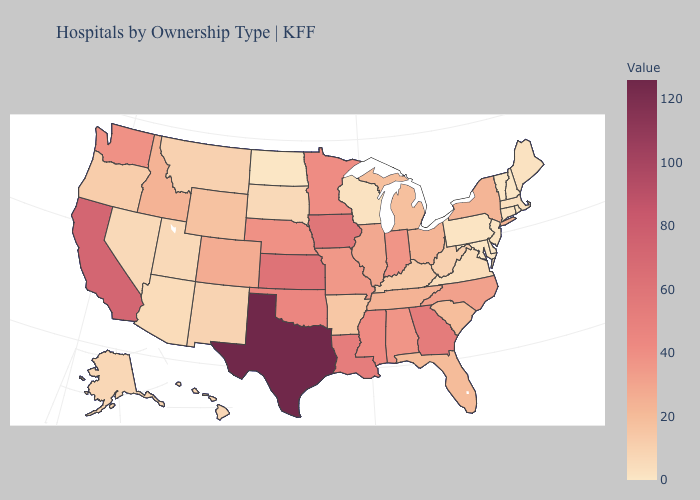Does the map have missing data?
Write a very short answer. No. Which states have the highest value in the USA?
Quick response, please. Texas. Does the map have missing data?
Be succinct. No. Does Florida have a higher value than Kansas?
Answer briefly. No. Among the states that border North Carolina , does Virginia have the highest value?
Short answer required. No. Does Connecticut have the lowest value in the USA?
Answer briefly. No. 